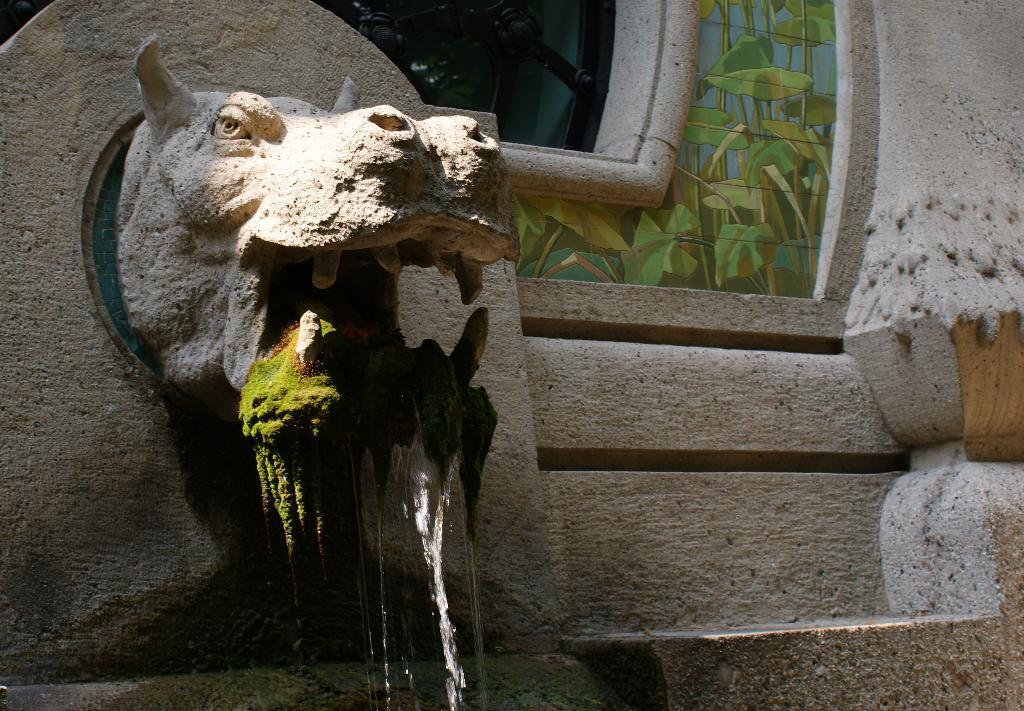What is the main subject in the image? There is a sculpture in the image. Can you describe any other features in the image? There is a window in the image, and there are plant images on the glass of the window. Is there any natural element visible in the image? Yes, there is water visible in the image. What type of bat can be seen flying near the sculpture in the image? There is no bat present in the image; it only features a sculpture, a window with plant images, and water. 